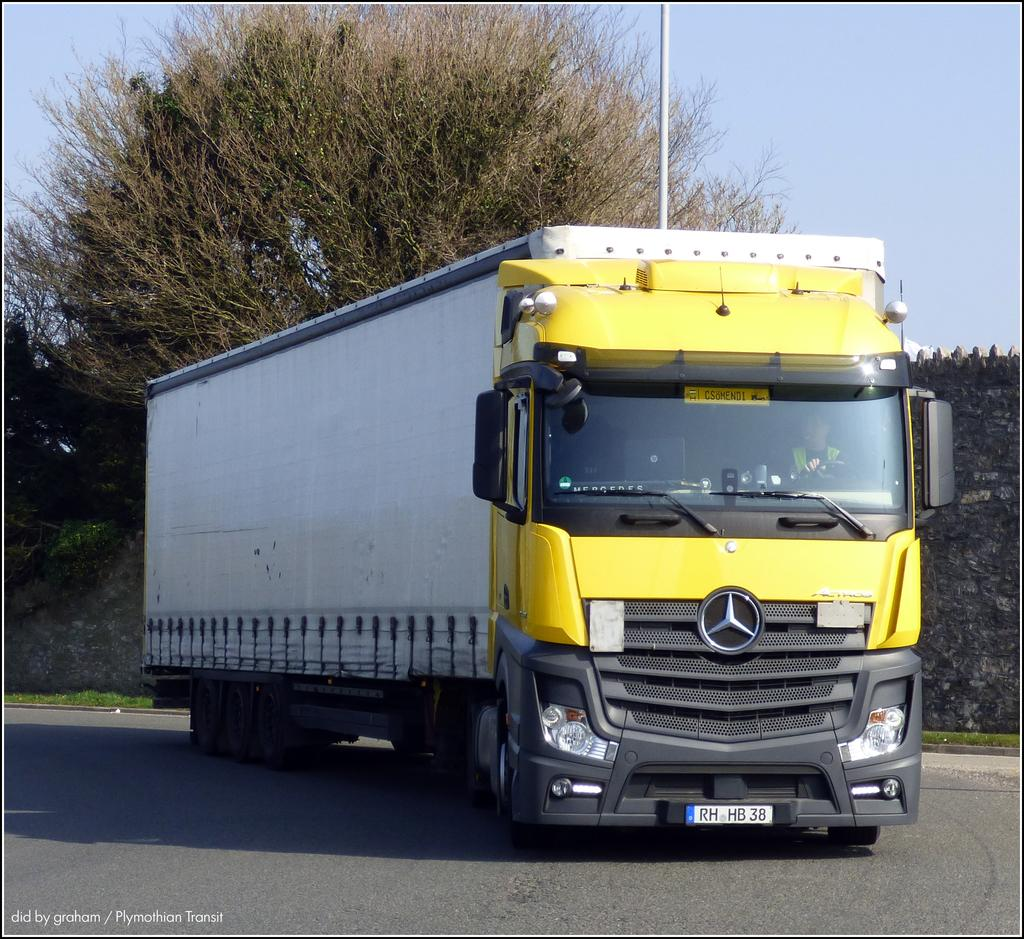What is happening in the image? There is a vehicle moving on the road in the image. What can be seen in the background of the image? There is a wall and trees visible in the background of the image. What invention is being used by the dogs in the image? There are no dogs or inventions present in the image. 